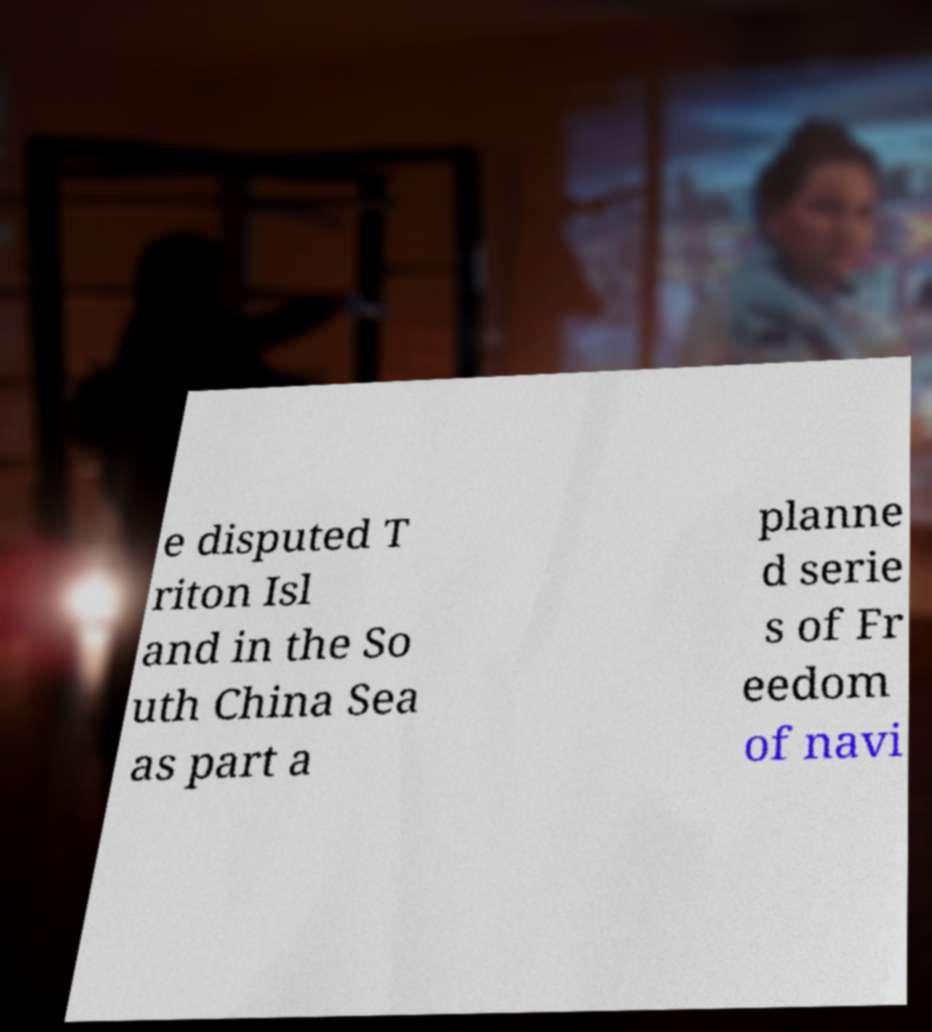Could you extract and type out the text from this image? e disputed T riton Isl and in the So uth China Sea as part a planne d serie s of Fr eedom of navi 